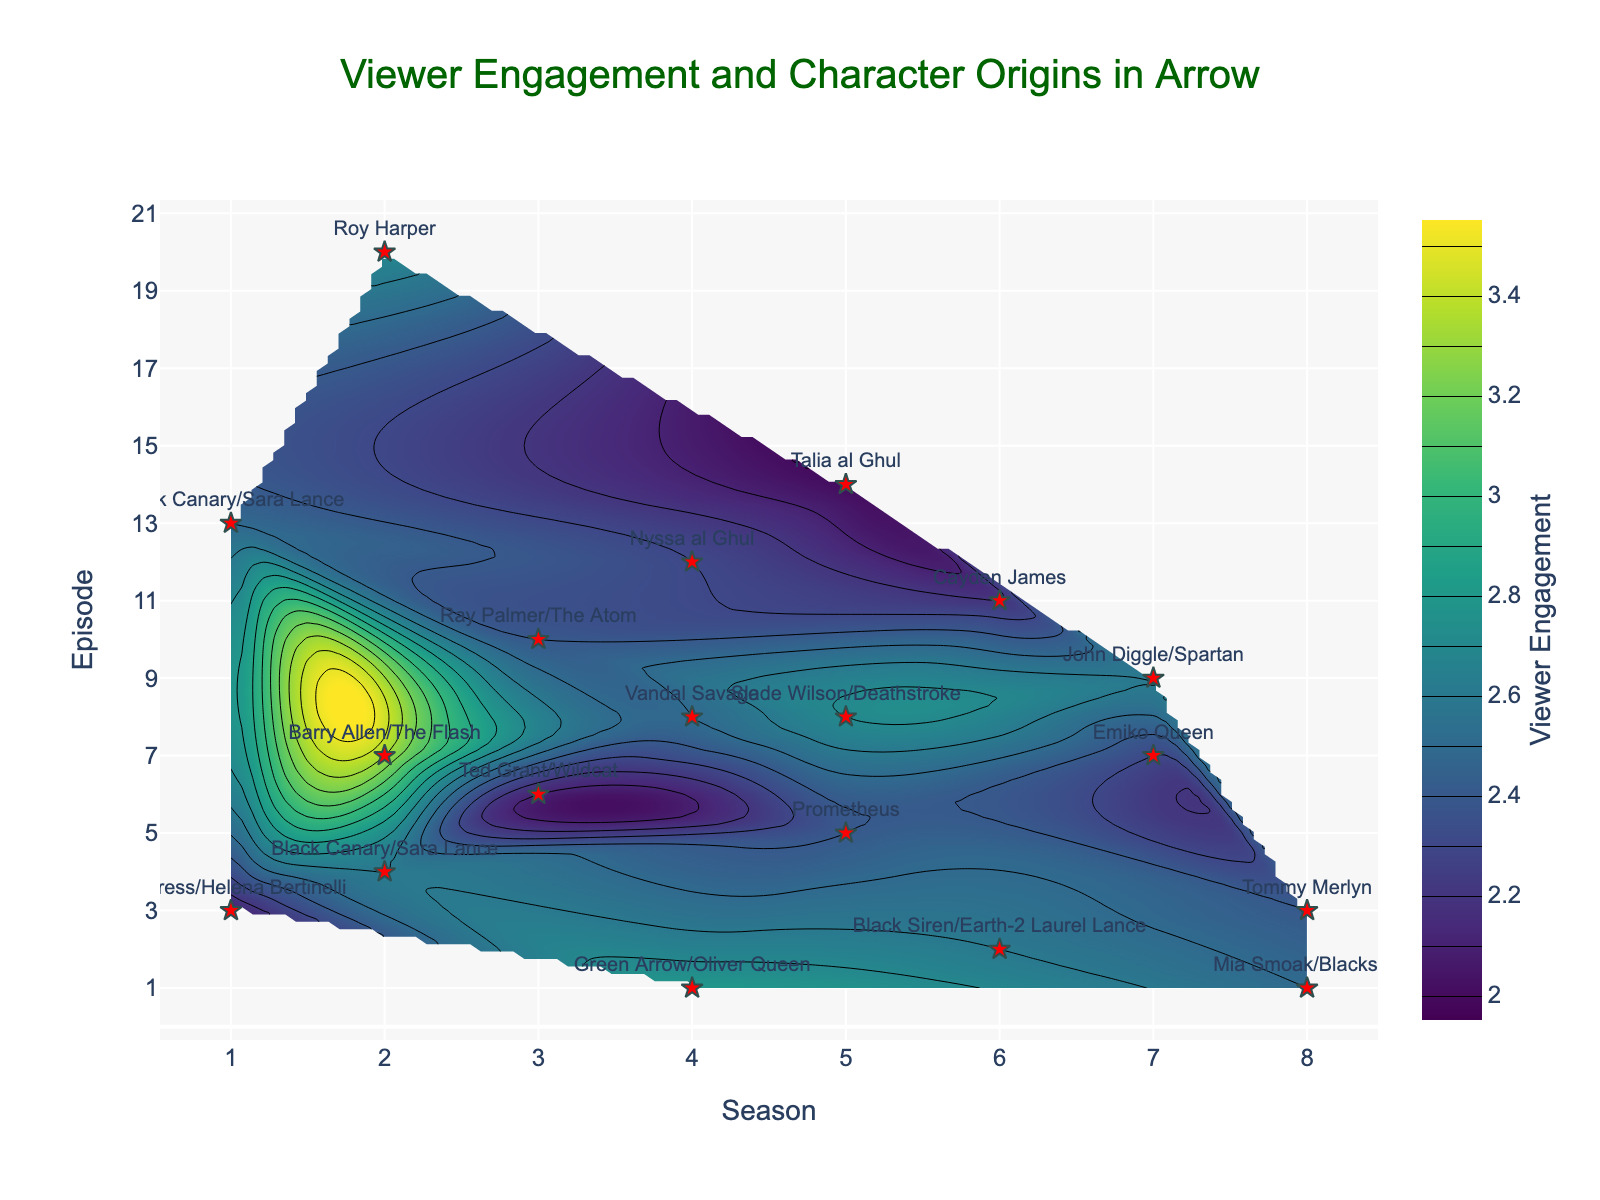What is the title of the plot? The title is prominently displayed at the top center of the plot, stating the main focus of the visual representation. The title reads "Viewer Engagement and Character Origins in Arrow".
Answer: Viewer Engagement and Character Origins in Arrow How many seasons are depicted in the plot? The x-axis represents the seasons and is labeled from 1 to 8. This indicates the range of seasons covered in the plot.
Answer: 8 Which character origin episode has the highest viewer engagement? By looking at the scatter plot, we can identify the red star marker that is also located on the highest part of the contour which indicates higher engagement. This marker is for Barry Allen/The Flash in Season 2, Episode 7, with an engagement of 3.3.
Answer: Barry Allen/The Flash In which season and episode did the character origin of Prometheus appear? The scatter plot shows that Prometheus is labeled at the position corresponding to Season 5 and Episode 5.
Answer: Season 5, Episode 5 How does the viewer engagement for John Diggle/Spartan compare to Black Siren/Earth-2 Laurel Lance? John Diggle/Spartan's episode is in Season 7, Episode 9 with an engagement of 2.6, while Black Siren/Earth-2 Laurel Lance's episode is in Season 6, Episode 2 with the same engagement of 2.6. They have equal viewer engagement.
Answer: Equal On average, which seasons have higher viewer engagement: Seasons 1-4 or Seasons 5-8? To find this, take the viewer engagement averages for seasons 1-4 and seasons 5-8:
Average for Seasons 1-4: (2.1+2.5+2.6+3.3+2.7+2.1+2.4+2.8+2.5+2.3)/10 = 2.53
Average for Seasons 5-8: (2.4+2.7+2.0+2.6+2.2+2.3+2.6+2.5+2.4)/9 = 2.42
Seasons 1-4 have a higher average.
Answer: Seasons 1-4 Is there a notable trend in viewer engagement for origins in the later seasons (6-8) compared to earlier seasons (1-3)? Reviewing the scatter points and contour colors, the viewer engagements in the later seasons typically average around 2.4 to 2.6, whereas some earlier-season episodes, specifically for characters like Barry Allen/The Flash, reach as high as 3.3. Thus, viewer engagement tends to be slightly lower or more consistent in later seasons.
Answer: Engagement is slightly lower in later seasons What range of viewer engagements is represented by the color gradient in the contour plot? The color gradient of the contour plot, indicated by the color bar, represents viewer engagements ranging from 2 to 3.5.
Answer: 2 to 3.5 Which season has the most character origin episodes based on the scatter plot? By counting the red star markers for each season, Season 2 has the most character origin episodes with three markers for Black Canary (Sara Lance), Barry Allen/The Flash, and Roy Harper.
Answer: Season 2 